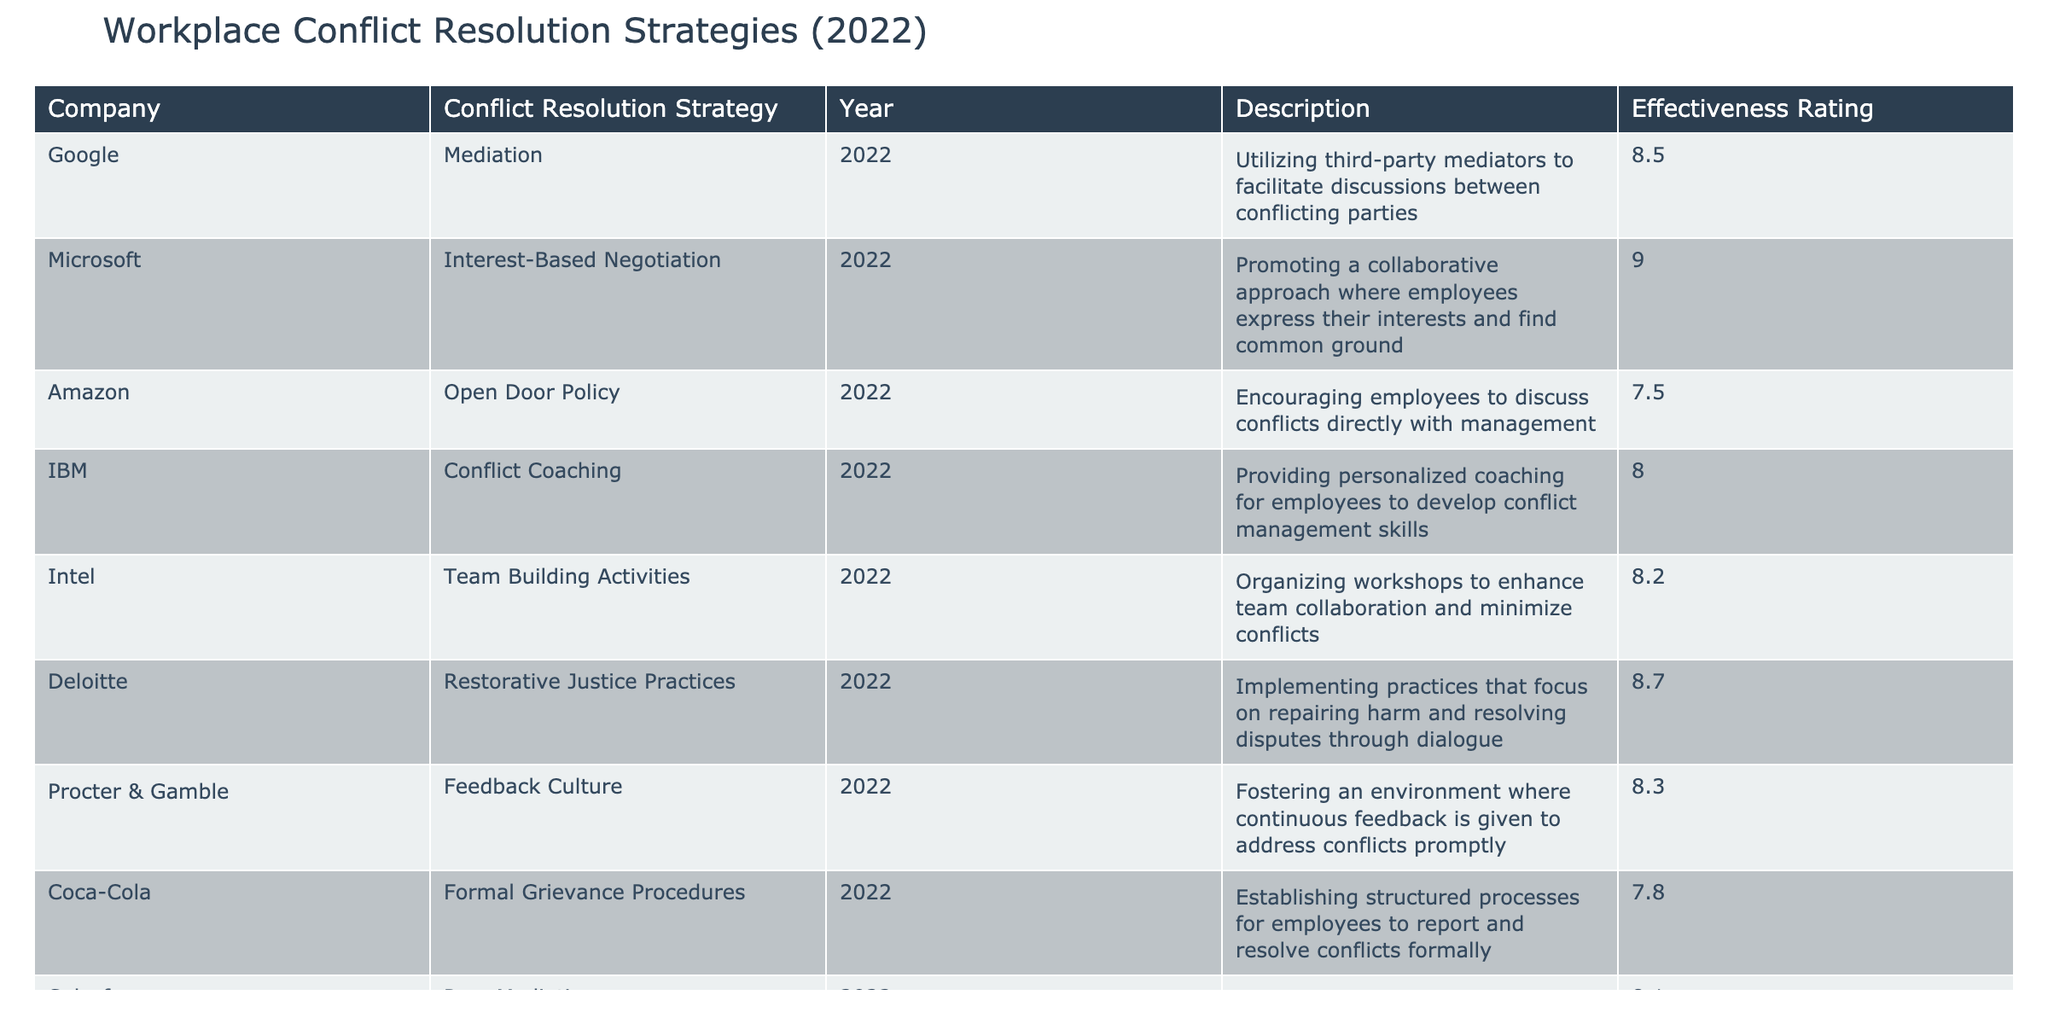What is the effectiveness rating of the Open Door Policy strategy employed by Amazon? The effectiveness rating for the Open Door Policy is listed directly in the table under Amazon's row. The value is 7.5.
Answer: 7.5 Which company has the highest effectiveness rating for conflict resolution strategies? By checking each effectiveness rating in the table, it is clear that Microsoft has the highest rating of 9.0.
Answer: Microsoft What is the average effectiveness rating of all the conflict resolution strategies listed in the table? To calculate the average, we need to sum the effectiveness ratings: 8.5 + 9.0 + 7.5 + 8.0 + 8.2 + 8.7 + 8.3 + 7.8 + 8.1 + 7.9 = 83.0. Then, we divide that by the number of strategies (10): 83.0 / 10 = 8.3.
Answer: 8.3 Does Facebook employ a strategy that involves mediation as a conflict resolution approach? By reviewing the table, Facebook employs an Anonymous Reporting System, not a mediation strategy. Thus, the answer is no.
Answer: No What are the conflict resolution strategies that received effectiveness ratings above 8.0? By looking through the table, the strategies with ratings above 8.0 include: Mediation (8.5), Interest-Based Negotiation (9.0), Conflict Coaching (8.0), Team Building Activities (8.2), Restorative Justice Practices (8.7), Feedback Culture (8.3), and Peer Mediation (8.1).
Answer: Mediation, Interest-Based Negotiation, Conflict Coaching, Team Building Activities, Restorative Justice Practices, Feedback Culture, Peer Mediation Which strategy received the lowest effectiveness rating and what was the rating? We can find the lowest rating by examining all listed effectiveness ratings. The Formal Grievance Procedures associated with Coca-Cola has the lowest rating of 7.8.
Answer: Formal Grievance Procedures, 7.8 Do any of the strategies employ a third-party mediator in their approach? Only the Mediation strategy by Google involves a third-party mediator, as indicated in the description. Therefore, the answer is yes.
Answer: Yes What is the difference between the effectiveness ratings of Interest-Based Negotiation and Anonymous Reporting System? The effectiveness rating for Interest-Based Negotiation is 9.0 and for Anonymous Reporting System is 7.9. The difference is calculated as 9.0 - 7.9 = 1.1.
Answer: 1.1 Which strategies utilize a team-oriented approach for conflict resolution? By analyzing the table, the strategies that emphasize a team-oriented approach include Team Building Activities (Intel) and Peer Mediation (Salesforce). Thus, both target teamwork.
Answer: Team Building Activities, Peer Mediation 